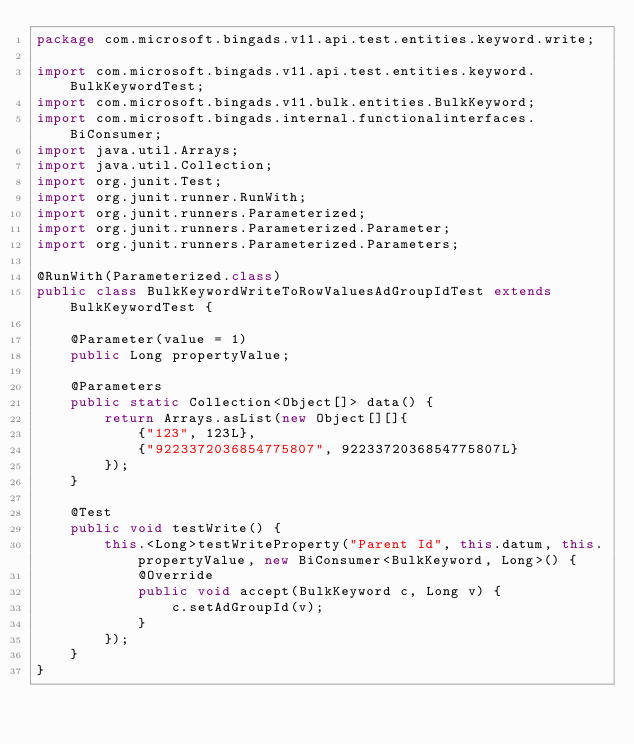<code> <loc_0><loc_0><loc_500><loc_500><_Java_>package com.microsoft.bingads.v11.api.test.entities.keyword.write;

import com.microsoft.bingads.v11.api.test.entities.keyword.BulkKeywordTest;
import com.microsoft.bingads.v11.bulk.entities.BulkKeyword;
import com.microsoft.bingads.internal.functionalinterfaces.BiConsumer;
import java.util.Arrays;
import java.util.Collection;
import org.junit.Test;
import org.junit.runner.RunWith;
import org.junit.runners.Parameterized;
import org.junit.runners.Parameterized.Parameter;
import org.junit.runners.Parameterized.Parameters;

@RunWith(Parameterized.class)
public class BulkKeywordWriteToRowValuesAdGroupIdTest extends BulkKeywordTest {

    @Parameter(value = 1)
    public Long propertyValue;

    @Parameters
    public static Collection<Object[]> data() {
        return Arrays.asList(new Object[][]{
            {"123", 123L},
            {"9223372036854775807", 9223372036854775807L}
        });
    }

    @Test
    public void testWrite() {
        this.<Long>testWriteProperty("Parent Id", this.datum, this.propertyValue, new BiConsumer<BulkKeyword, Long>() {
            @Override
            public void accept(BulkKeyword c, Long v) {
                c.setAdGroupId(v);
            }
        });
    }
}
</code> 